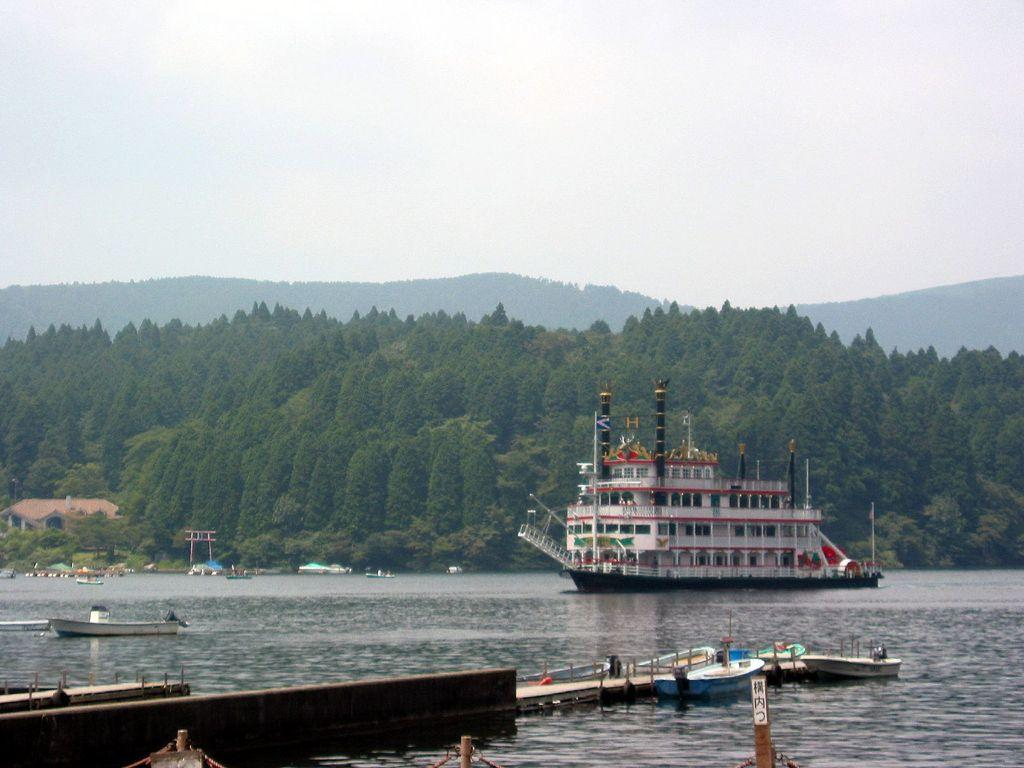What type of vehicles can be seen in the image? There are boats and a ship in the image. Where are the boats and ship located? The boats and ship are on the water in the image. What other structures or elements can be seen in the image? There is a building, trees, mountains, and some objects in the image. What is visible in the background of the image? The sky is visible in the background of the image. What does your brother's chicken have to do with the history of the boats in the image? There is no mention of a brother, chicken, or history in the image. The image only features boats, a ship, water, a building, trees, mountains, objects, and the sky. 